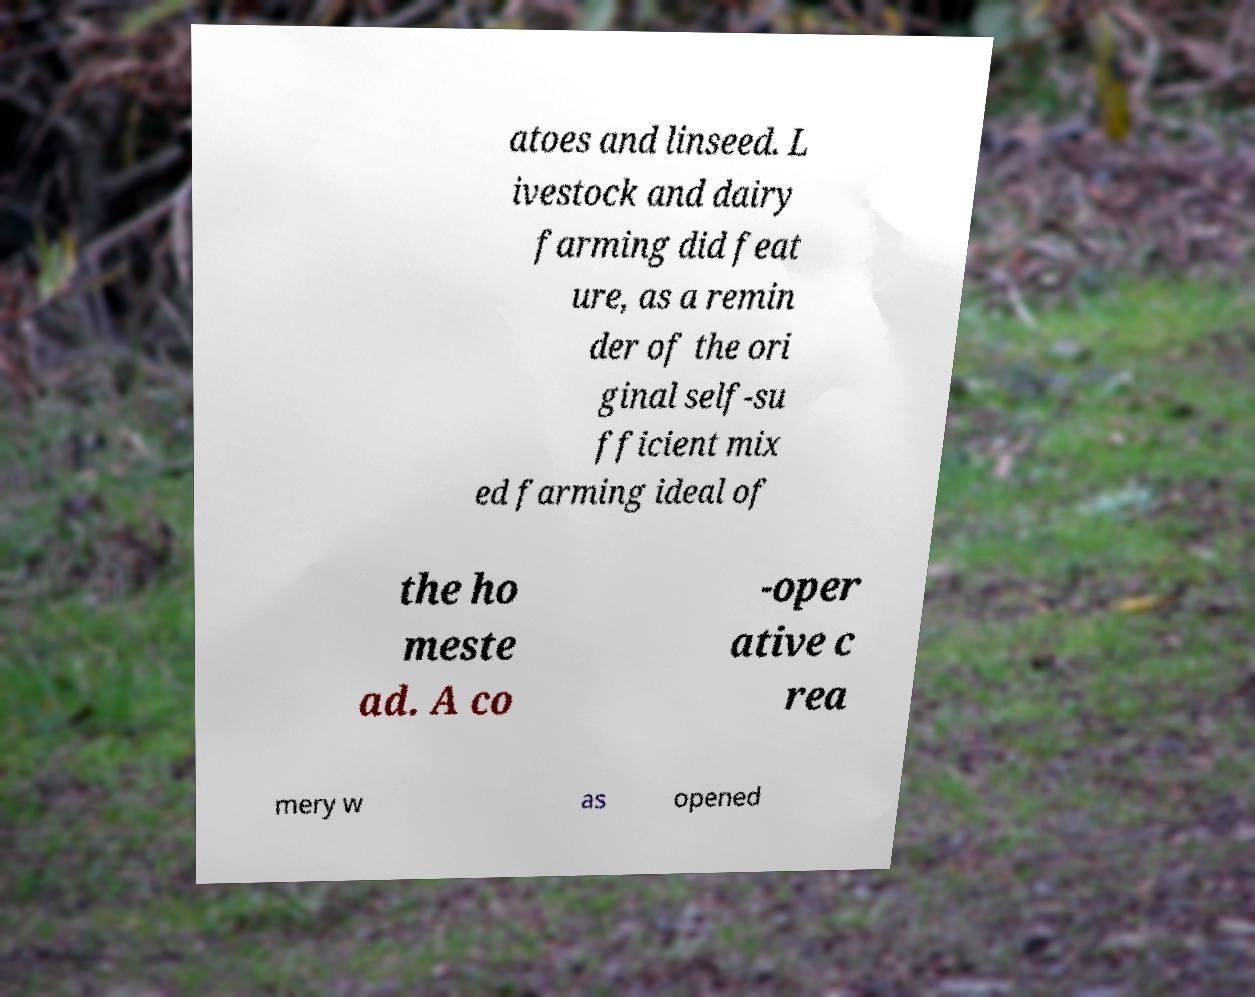For documentation purposes, I need the text within this image transcribed. Could you provide that? atoes and linseed. L ivestock and dairy farming did feat ure, as a remin der of the ori ginal self-su fficient mix ed farming ideal of the ho meste ad. A co -oper ative c rea mery w as opened 